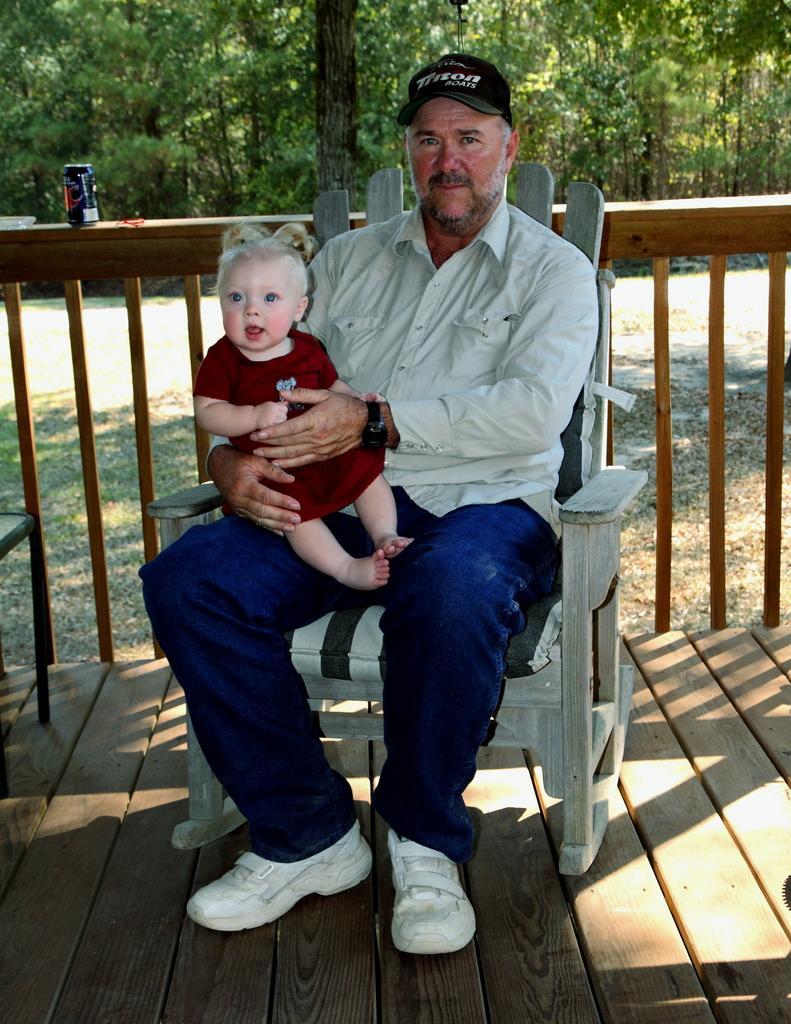Could you give a brief overview of what you see in this image? This picture shows a man and a boy seated on the chair and we see few trees back of them and we see a wooden fence 